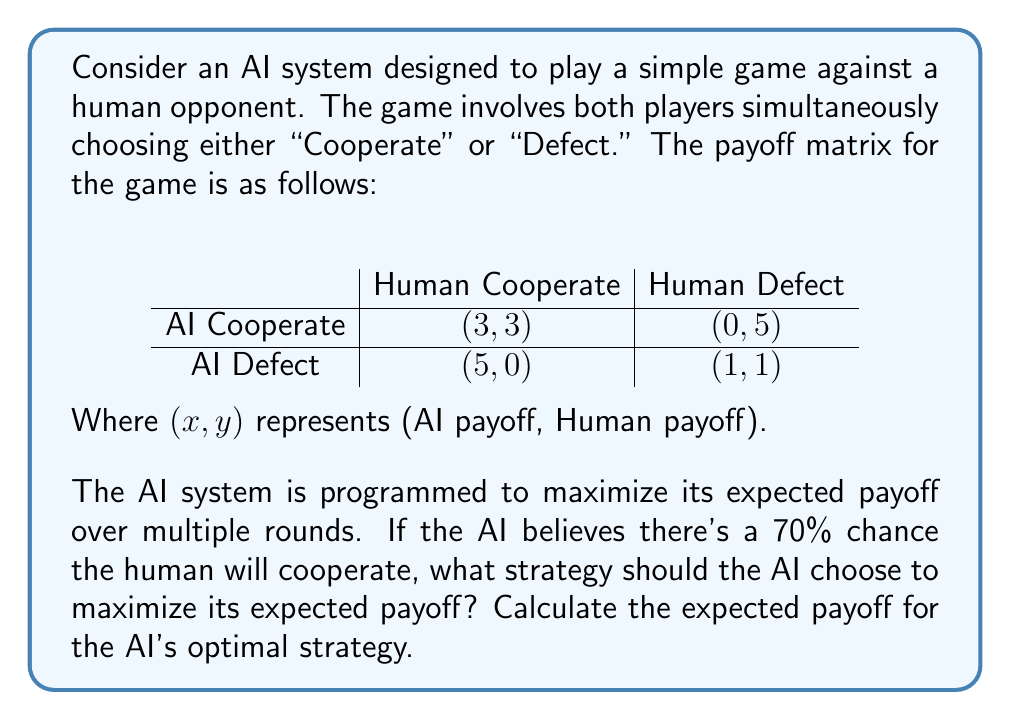Can you solve this math problem? To solve this problem, we need to calculate the expected payoff for each of the AI's possible strategies (Cooperate or Defect) given the probability of the human's actions.

Let's define:
$p$ = probability of human cooperating = 0.7
$1-p$ = probability of human defecting = 0.3

1. Expected payoff if AI chooses to Cooperate:
   $E(\text{Cooperate}) = 3p + 0(1-p) = 3(0.7) + 0(0.3) = 2.1$

2. Expected payoff if AI chooses to Defect:
   $E(\text{Defect}) = 5p + 1(1-p) = 5(0.7) + 1(0.3) = 3.8$

Since 3.8 > 2.1, the AI should choose to Defect to maximize its expected payoff.

The expected payoff for the AI's optimal strategy (Defect) is 3.8.

This example demonstrates how game theory can be used to model decision-making processes in AI systems. The AI uses probabilistic reasoning to determine the best course of action based on the expected behavior of its opponent and the given payoff structure.
Answer: The AI should choose to Defect. The expected payoff for this optimal strategy is 3.8. 